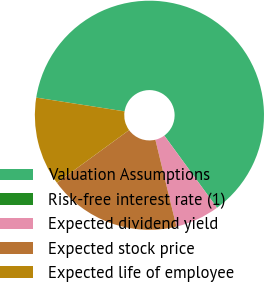Convert chart. <chart><loc_0><loc_0><loc_500><loc_500><pie_chart><fcel>Valuation Assumptions<fcel>Risk-free interest rate (1)<fcel>Expected dividend yield<fcel>Expected stock price<fcel>Expected life of employee<nl><fcel>62.49%<fcel>0.01%<fcel>6.25%<fcel>18.75%<fcel>12.5%<nl></chart> 